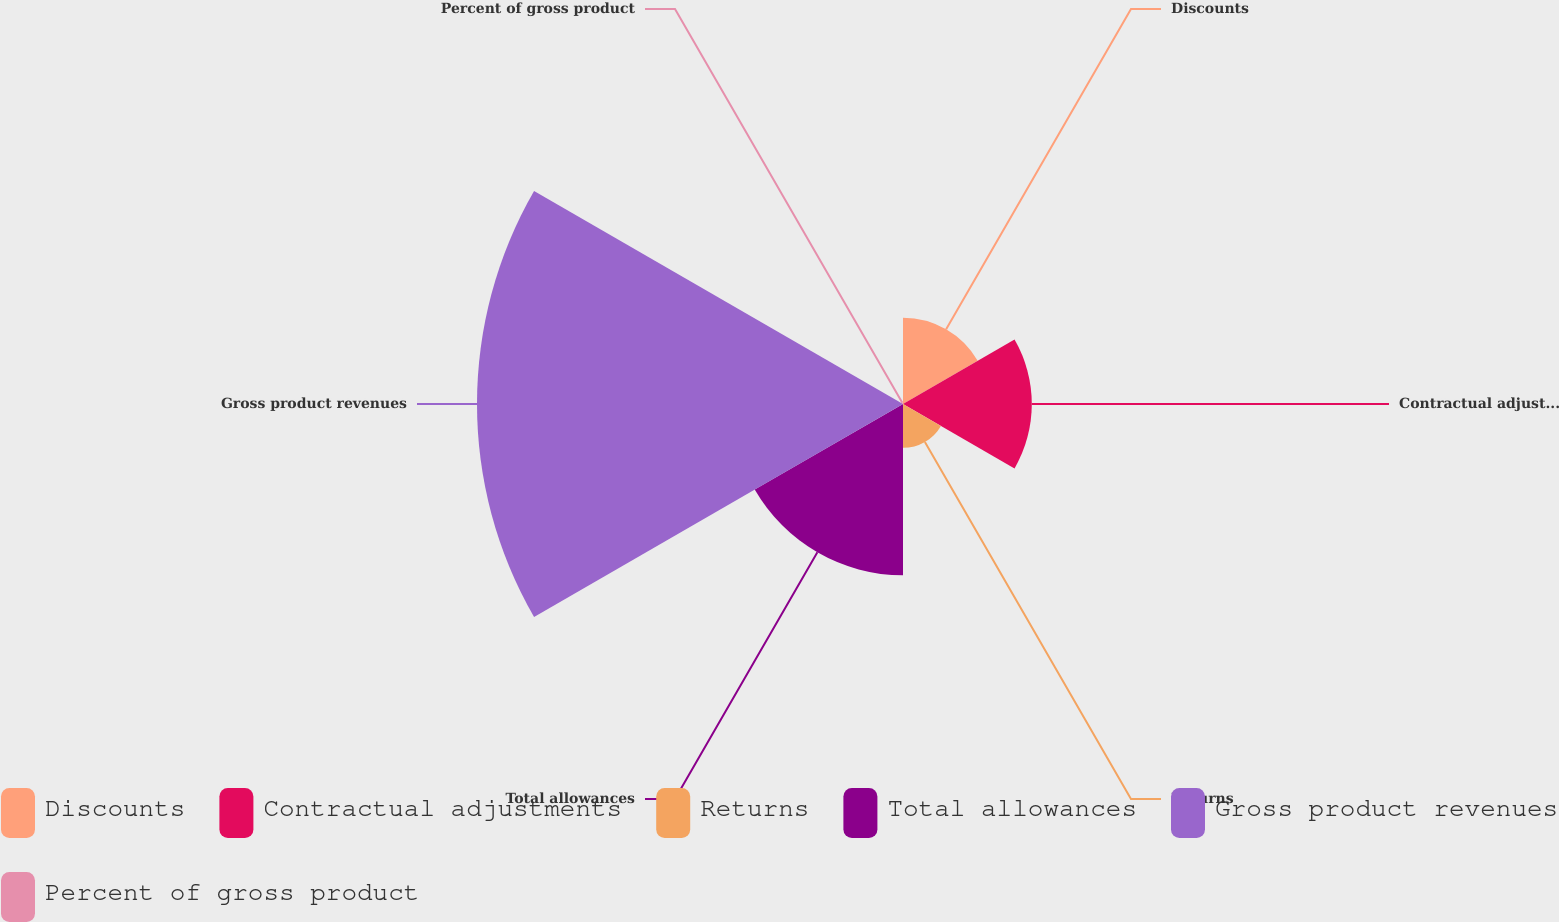<chart> <loc_0><loc_0><loc_500><loc_500><pie_chart><fcel>Discounts<fcel>Contractual adjustments<fcel>Returns<fcel>Total allowances<fcel>Gross product revenues<fcel>Percent of gross product<nl><fcel>10.06%<fcel>15.02%<fcel>5.11%<fcel>19.97%<fcel>49.68%<fcel>0.16%<nl></chart> 